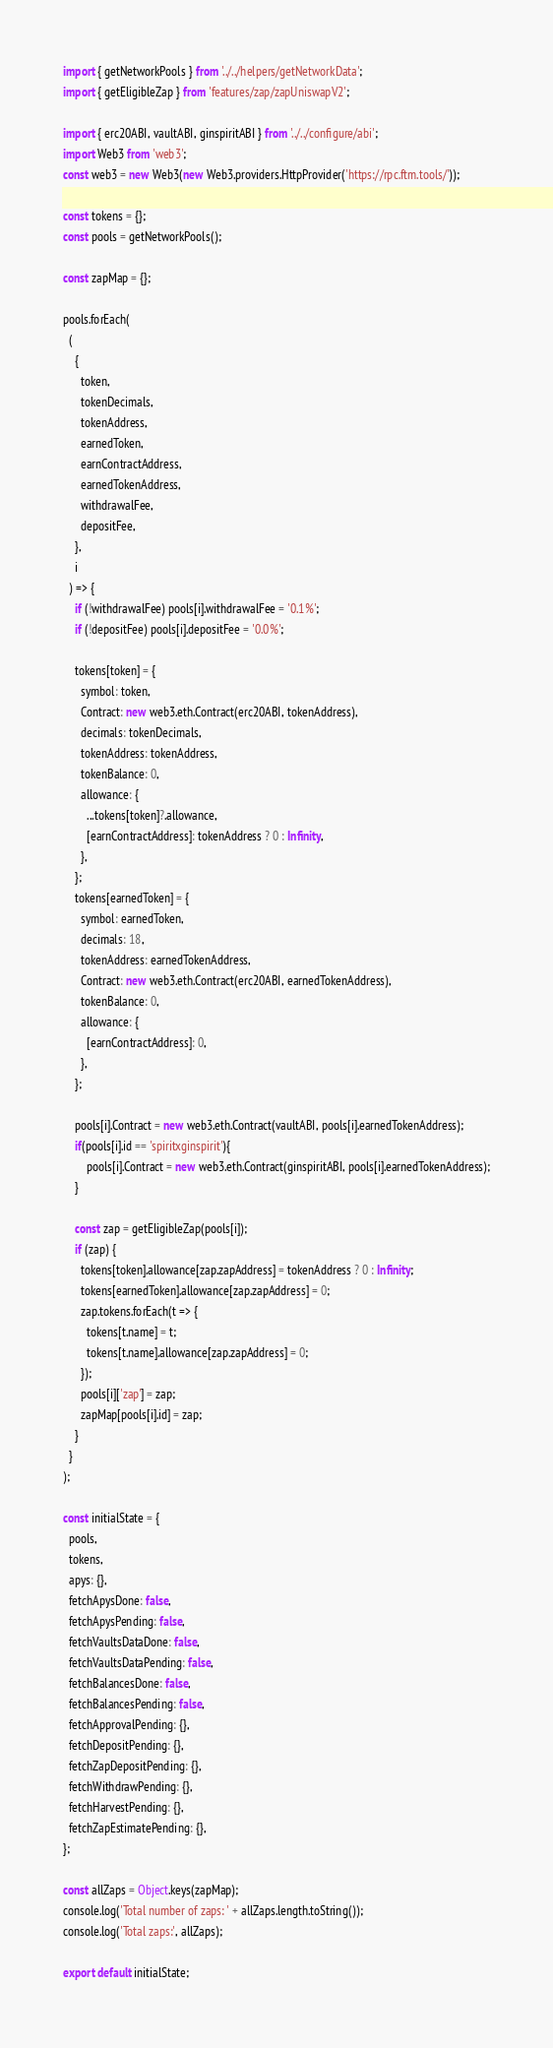<code> <loc_0><loc_0><loc_500><loc_500><_JavaScript_>import { getNetworkPools } from '../../helpers/getNetworkData';
import { getEligibleZap } from 'features/zap/zapUniswapV2';

import { erc20ABI, vaultABI, ginspiritABI } from '../../configure/abi';
import Web3 from 'web3';
const web3 = new Web3(new Web3.providers.HttpProvider('https://rpc.ftm.tools/'));

const tokens = {};
const pools = getNetworkPools();

const zapMap = {};

pools.forEach(
  (
    {
      token,
      tokenDecimals,
      tokenAddress,
      earnedToken,
      earnContractAddress,
      earnedTokenAddress,
      withdrawalFee,
      depositFee,
    },
    i
  ) => {
    if (!withdrawalFee) pools[i].withdrawalFee = '0.1%';
    if (!depositFee) pools[i].depositFee = '0.0%';

    tokens[token] = {
      symbol: token,
      Contract: new web3.eth.Contract(erc20ABI, tokenAddress),
      decimals: tokenDecimals,
      tokenAddress: tokenAddress,
      tokenBalance: 0,
      allowance: {
        ...tokens[token]?.allowance,
        [earnContractAddress]: tokenAddress ? 0 : Infinity,
      },
    };
    tokens[earnedToken] = {
      symbol: earnedToken,
      decimals: 18,
      tokenAddress: earnedTokenAddress,
      Contract: new web3.eth.Contract(erc20ABI, earnedTokenAddress),
      tokenBalance: 0,
      allowance: {
        [earnContractAddress]: 0,
      },
    };

    pools[i].Contract = new web3.eth.Contract(vaultABI, pools[i].earnedTokenAddress);
    if(pools[i].id == 'spiritxginspirit'){
        pools[i].Contract = new web3.eth.Contract(ginspiritABI, pools[i].earnedTokenAddress);
    }

    const zap = getEligibleZap(pools[i]);
    if (zap) {
      tokens[token].allowance[zap.zapAddress] = tokenAddress ? 0 : Infinity;
      tokens[earnedToken].allowance[zap.zapAddress] = 0;
      zap.tokens.forEach(t => {
        tokens[t.name] = t;
        tokens[t.name].allowance[zap.zapAddress] = 0;
      });
      pools[i]['zap'] = zap;
      zapMap[pools[i].id] = zap;
    }
  }
);

const initialState = {
  pools,
  tokens,
  apys: {},
  fetchApysDone: false,
  fetchApysPending: false,
  fetchVaultsDataDone: false,
  fetchVaultsDataPending: false,
  fetchBalancesDone: false,
  fetchBalancesPending: false,
  fetchApprovalPending: {},
  fetchDepositPending: {},
  fetchZapDepositPending: {},
  fetchWithdrawPending: {},
  fetchHarvestPending: {},
  fetchZapEstimatePending: {},
};

const allZaps = Object.keys(zapMap);
console.log('Total number of zaps: ' + allZaps.length.toString());
console.log('Total zaps:', allZaps);

export default initialState;
</code> 